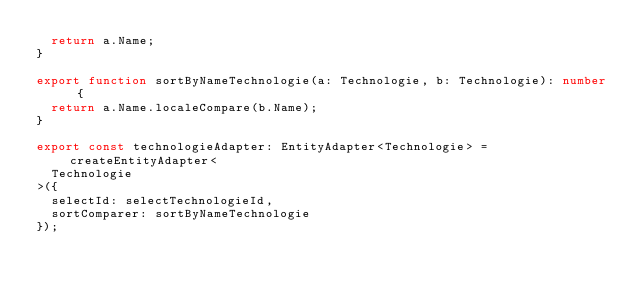Convert code to text. <code><loc_0><loc_0><loc_500><loc_500><_TypeScript_>  return a.Name;
}

export function sortByNameTechnologie(a: Technologie, b: Technologie): number {
  return a.Name.localeCompare(b.Name);
}

export const technologieAdapter: EntityAdapter<Technologie> = createEntityAdapter<
  Technologie
>({
  selectId: selectTechnologieId,
  sortComparer: sortByNameTechnologie
});
</code> 